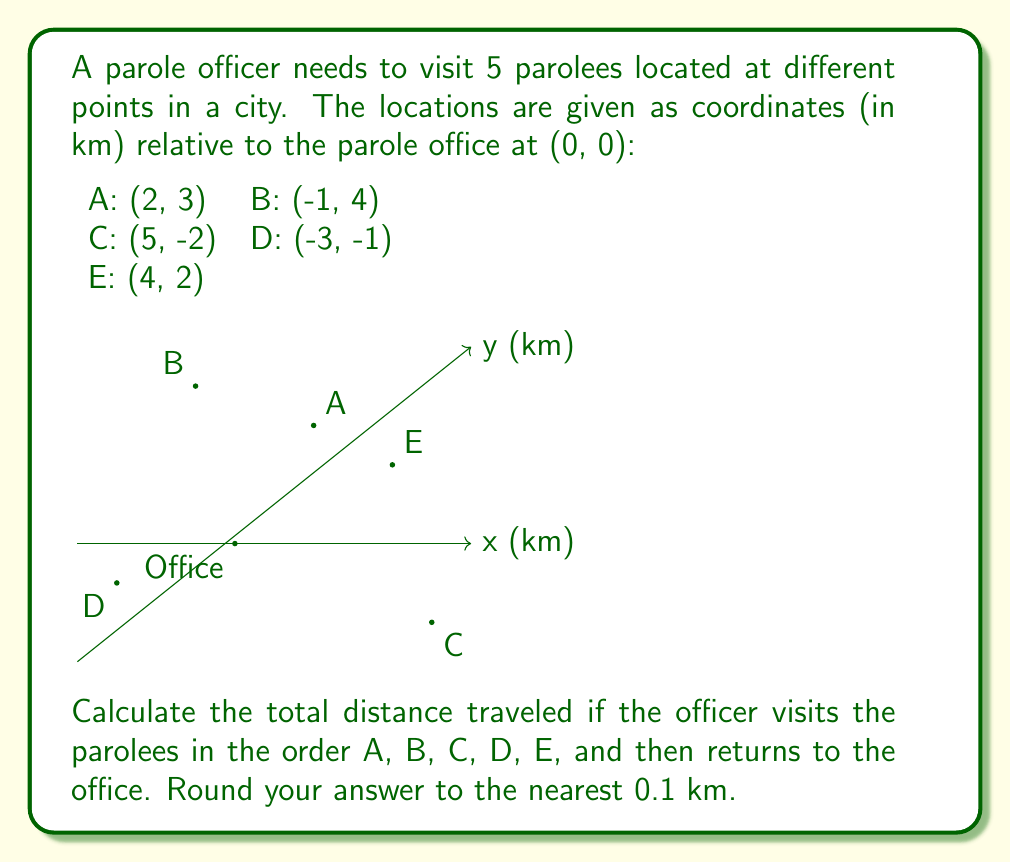What is the answer to this math problem? To solve this problem, we need to calculate the distance between consecutive points and sum them up. We'll use the distance formula between two points $(x_1, y_1)$ and $(x_2, y_2)$:

$$ d = \sqrt{(x_2 - x_1)^2 + (y_2 - y_1)^2} $$

Let's calculate each segment:

1. Office to A: 
   $d_{OA} = \sqrt{(2-0)^2 + (3-0)^2} = \sqrt{4 + 9} = \sqrt{13} \approx 3.6$ km

2. A to B: 
   $d_{AB} = \sqrt{(-1-2)^2 + (4-3)^2} = \sqrt{9 + 1} = \sqrt{10} \approx 3.2$ km

3. B to C: 
   $d_{BC} = \sqrt{(5-(-1))^2 + (-2-4)^2} = \sqrt{36 + 36} = \sqrt{72} \approx 8.5$ km

4. C to D: 
   $d_{CD} = \sqrt{(-3-5)^2 + (-1-(-2))^2} = \sqrt{64 + 1} = \sqrt{65} \approx 8.1$ km

5. D to E: 
   $d_{DE} = \sqrt{(4-(-3))^2 + (2-(-1))^2} = \sqrt{49 + 9} = \sqrt{58} \approx 7.6$ km

6. E back to Office: 
   $d_{EO} = \sqrt{(0-4)^2 + (0-2)^2} = \sqrt{16 + 4} = \sqrt{20} \approx 4.5$ km

Now, we sum up all these distances:

$$ \text{Total distance} = 3.6 + 3.2 + 8.5 + 8.1 + 7.6 + 4.5 = 35.5 \text{ km} $$

Rounding to the nearest 0.1 km, we get 35.5 km.
Answer: 35.5 km 